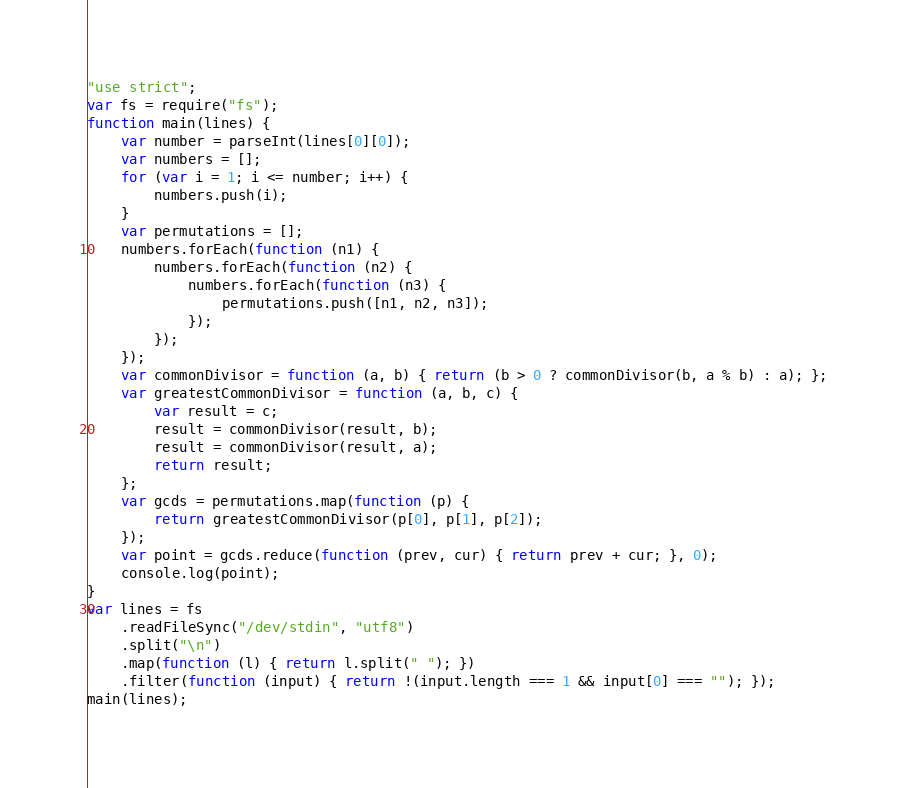<code> <loc_0><loc_0><loc_500><loc_500><_JavaScript_>"use strict";
var fs = require("fs");
function main(lines) {
    var number = parseInt(lines[0][0]);
    var numbers = [];
    for (var i = 1; i <= number; i++) {
        numbers.push(i);
    }
    var permutations = [];
    numbers.forEach(function (n1) {
        numbers.forEach(function (n2) {
            numbers.forEach(function (n3) {
                permutations.push([n1, n2, n3]);
            });
        });
    });
    var commonDivisor = function (a, b) { return (b > 0 ? commonDivisor(b, a % b) : a); };
    var greatestCommonDivisor = function (a, b, c) {
        var result = c;
        result = commonDivisor(result, b);
        result = commonDivisor(result, a);
        return result;
    };
    var gcds = permutations.map(function (p) {
        return greatestCommonDivisor(p[0], p[1], p[2]);
    });
    var point = gcds.reduce(function (prev, cur) { return prev + cur; }, 0);
    console.log(point);
}
var lines = fs
    .readFileSync("/dev/stdin", "utf8")
    .split("\n")
    .map(function (l) { return l.split(" "); })
    .filter(function (input) { return !(input.length === 1 && input[0] === ""); });
main(lines);
</code> 